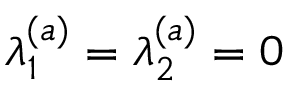Convert formula to latex. <formula><loc_0><loc_0><loc_500><loc_500>\lambda _ { 1 } ^ { ( a ) } = \lambda _ { 2 } ^ { ( a ) } = 0</formula> 